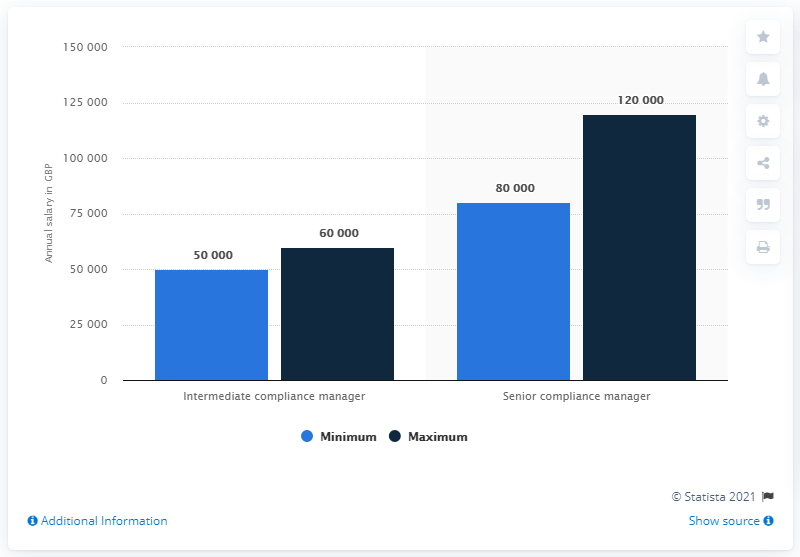Highlight a few significant elements in this photo. The average salary of a senior compliance manager is approximately $100,000 per year. The senior compliance manager typically earns more than a manager in the manger position. 